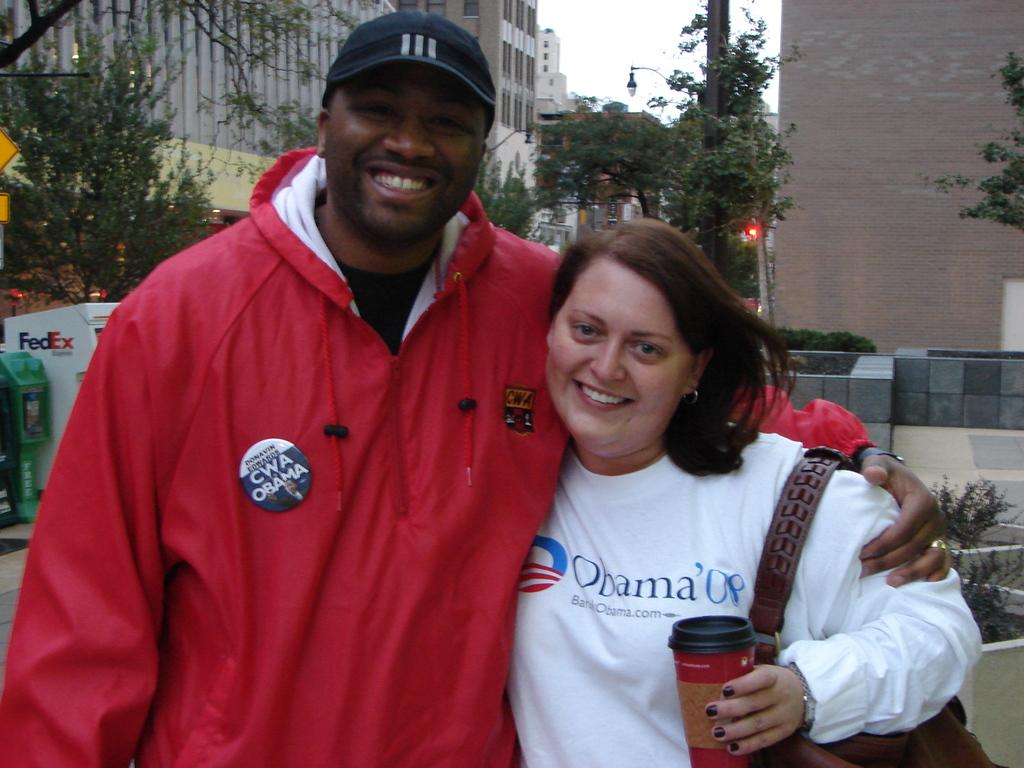Provide a one-sentence caption for the provided image. The girl in the white shirt has obama 08 on the front. 